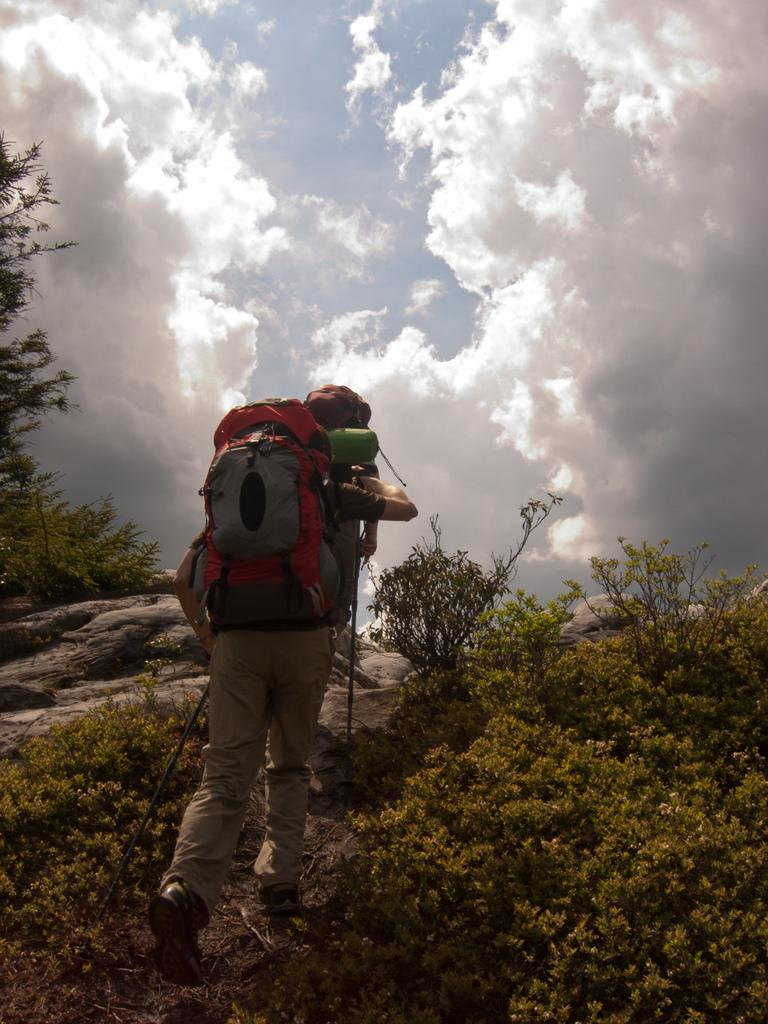What is the person in the image doing? The person is climbing a hill in the image. What protective gear is the person wearing? The person is wearing a helmet. What equipment is the person carrying? The person is wearing a backpack. What type of natural environment can be seen in the image? There are trees, plants, and rocks visible in the image. What is visible in the sky in the image? The sky is visible in the image, and it is full of clouds. What type of bed can be seen in the image? There is no bed present in the image; it features a person climbing a hill in a natural environment. What achievement has the person accomplished in the image? The image does not depict any specific achievement; it simply shows a person climbing a hill. 